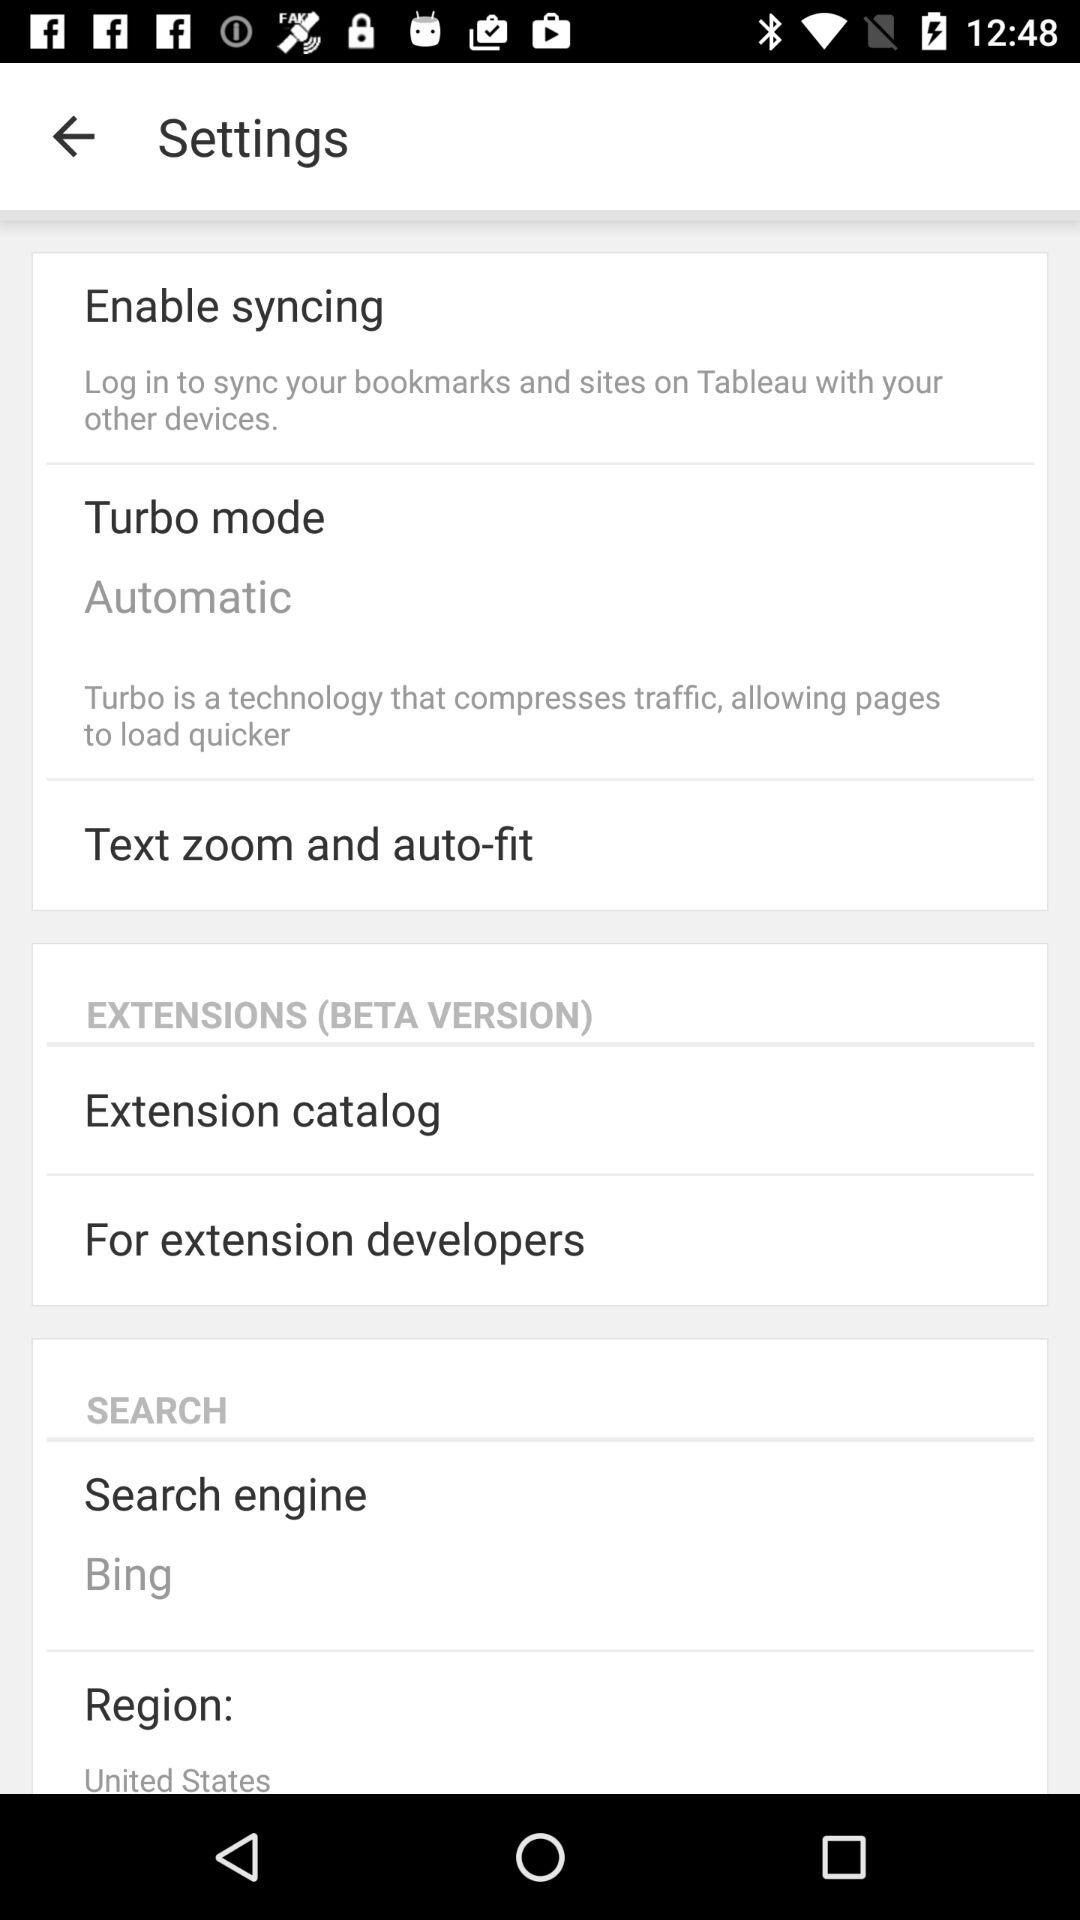What is the search engine? The search engine is "Bing". 